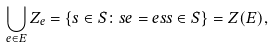Convert formula to latex. <formula><loc_0><loc_0><loc_500><loc_500>\bigcup _ { e \in E } Z _ { e } = \{ s \in S \colon s e = e s s \in S \} = Z ( E ) ,</formula> 